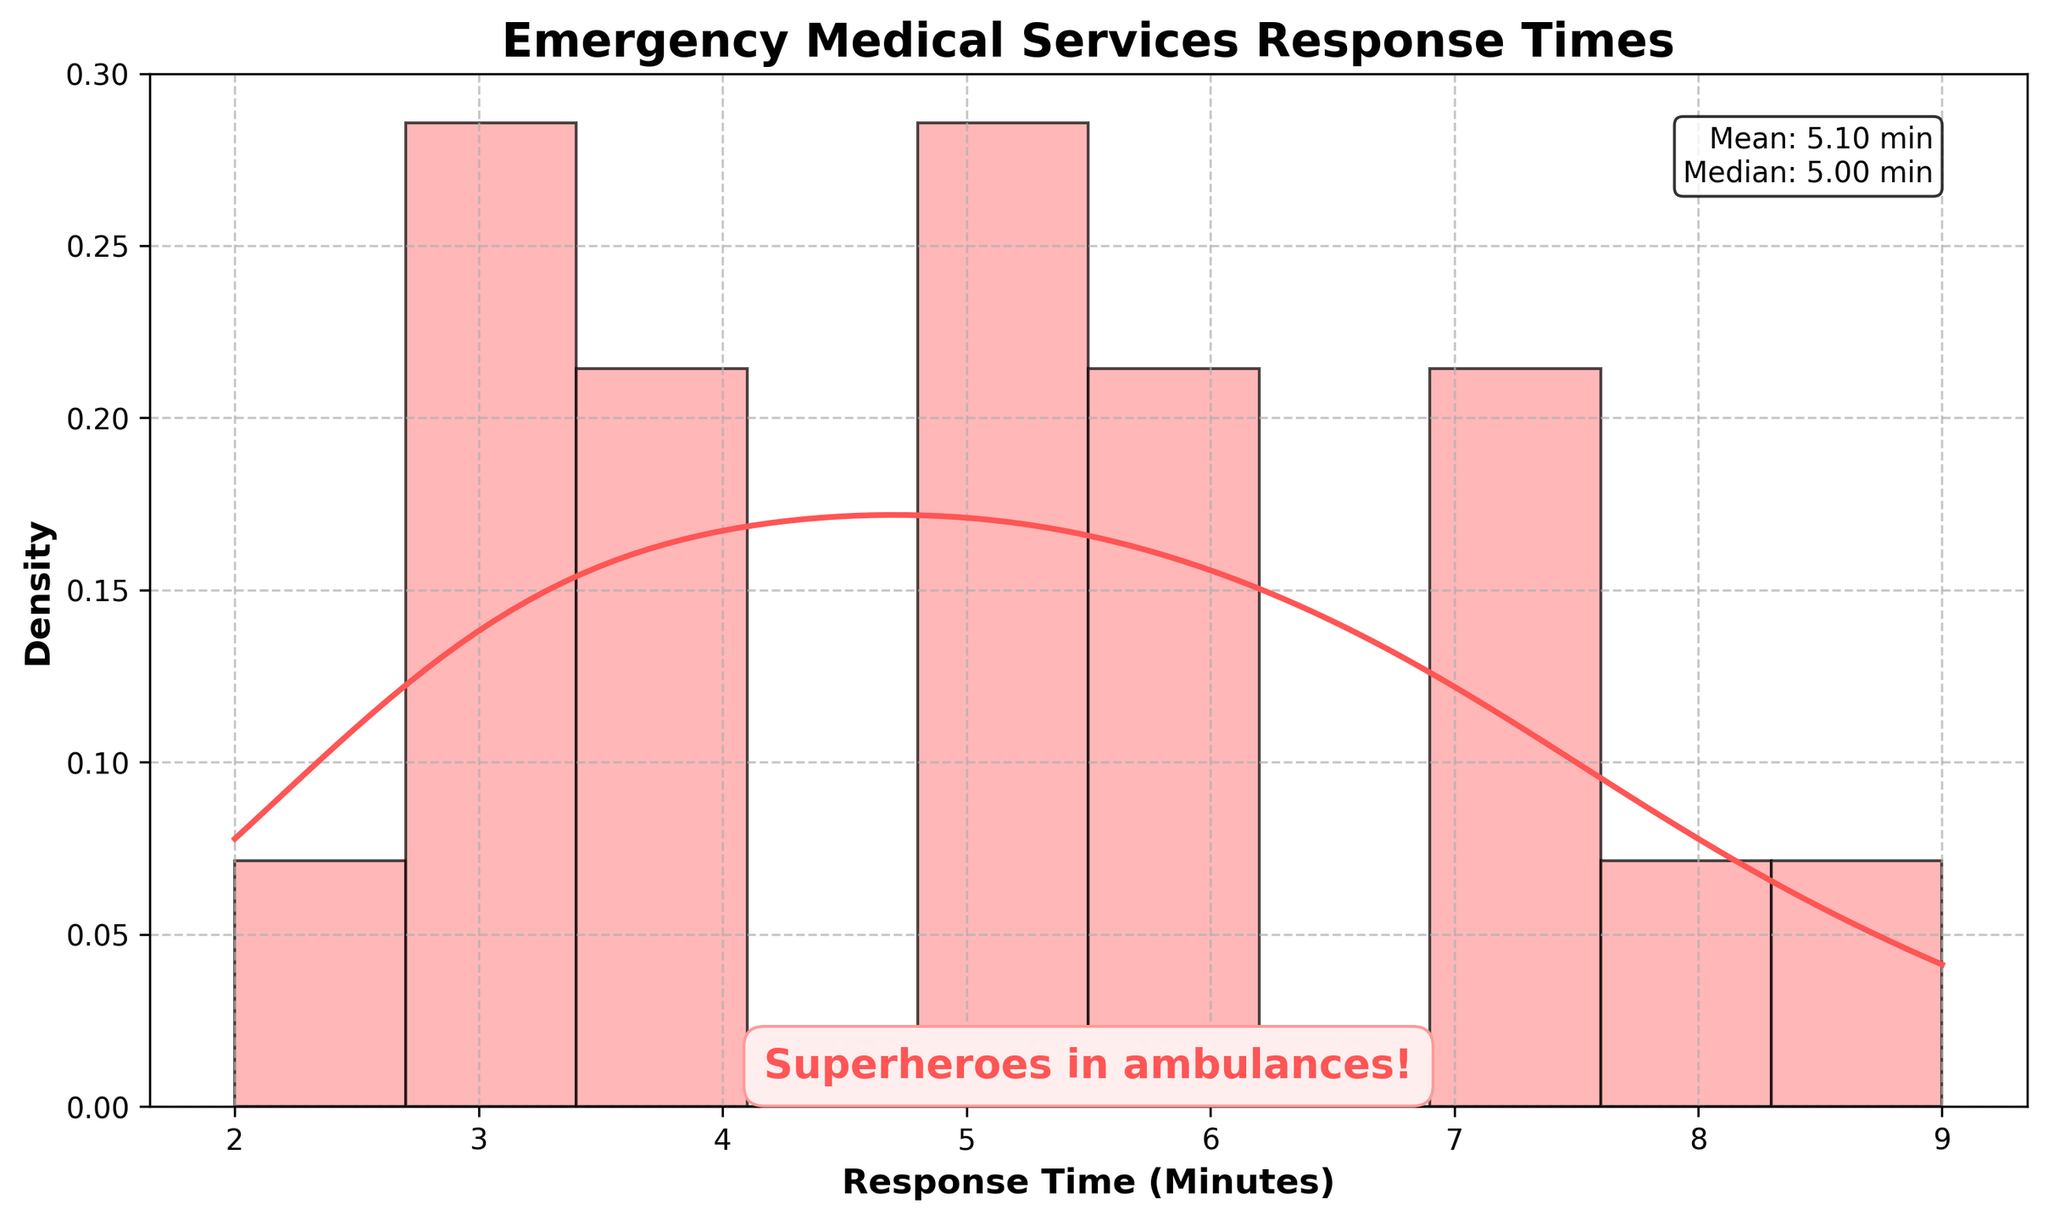What is the title of the figure? The title is displayed at the top of the figure and is typically used to describe what the figure represents. In this case, it reads "Emergency Medical Services Response Times."
Answer: Emergency Medical Services Response Times What is the mean response time for emergency medical services as shown in the figure? The mean (average) response time is provided in the statistics text box within the figure. It states "Mean: 5.00 min."
Answer: 5.00 min How many bins are used in the histogram displayed in the figure? Looking at the histogram, one can see the number of vertical bars (bins). The figure uses 10 bins, as specified in the data provided.
Answer: 10 Where is the highest peak in the KDE (density curve)? The KDE peak represents the highest density of response times. By inspecting the curve, the peak is around the response time of 5 minutes.
Answer: Around 5 minutes Which response time has the highest density according to the KDE curve? The KDE curve shows the density of response times. The highest point on the KDE curve is around 5 minutes.
Answer: Around 5 minutes What is the median response time for emergency medical services as shown in the figure? The median response time is provided in the statistics text box within the figure. It states "Median: 5.00 min."
Answer: 5.00 min What situation corresponds to the shortest response time? By referring to the data provided and matching it with the histogram, the shortest response time of 2 minutes is for "Soldier with heat exhaustion during training."
Answer: Soldier with heat exhaustion during training How does the density of response times change as the duration increases from 2 to 9 minutes? By examining the KDE curve, the density starts high around 2-4 minutes, reaches a peak around 5 minutes, and then gradually decreases from 6 to 9 minutes.
Answer: Increases initially, peaks at 5, then gradually decreases What can you infer about the frequency of response times around 5 minutes compared to 7 minutes? From the KDE curve and histogram, response times around 5 minutes are more frequent (denser) than those around 7 minutes, where the density is lower.
Answer: More frequent around 5 minutes What is the range of response times covered in the histogram? The range of response times is from the minimum to the maximum values shown in the histogram. The data ranges from 2 minutes to 9 minutes.
Answer: 2 to 9 minutes 